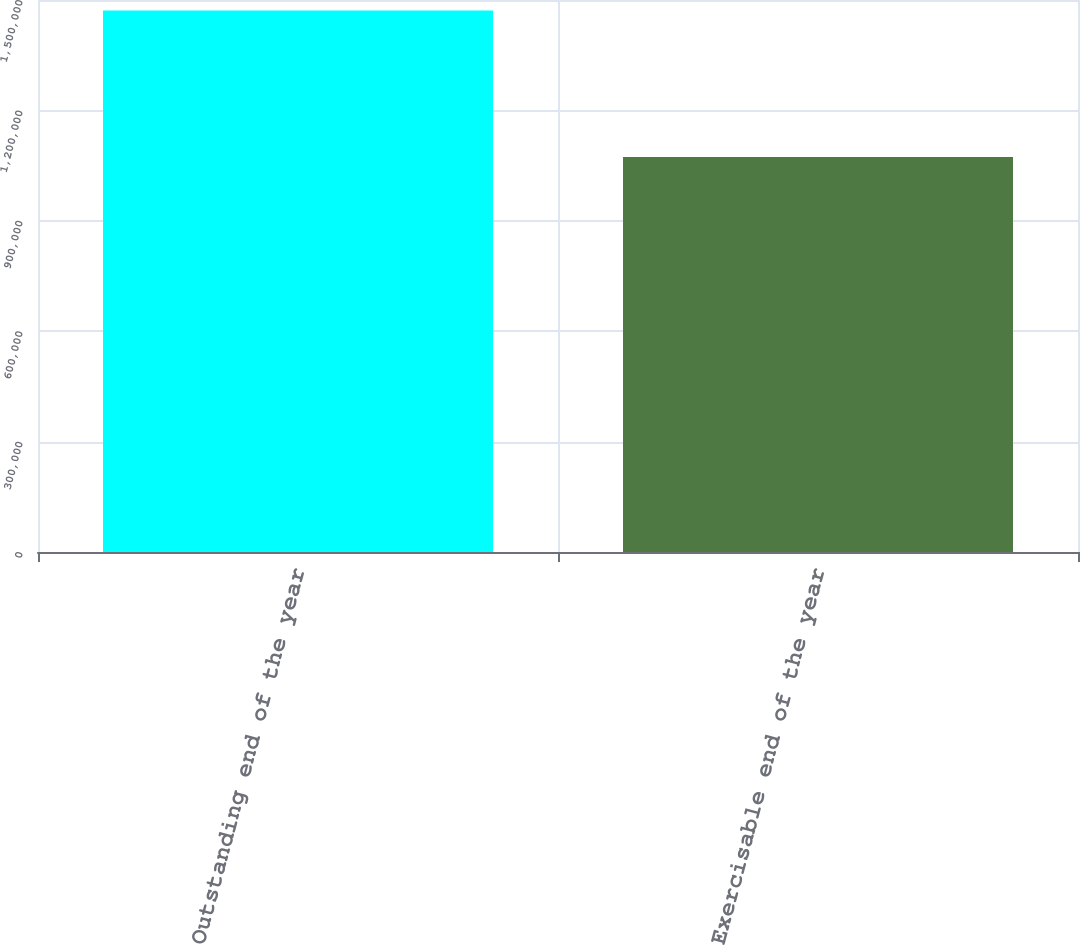<chart> <loc_0><loc_0><loc_500><loc_500><bar_chart><fcel>Outstanding end of the year<fcel>Exercisable end of the year<nl><fcel>1.47145e+06<fcel>1.0732e+06<nl></chart> 